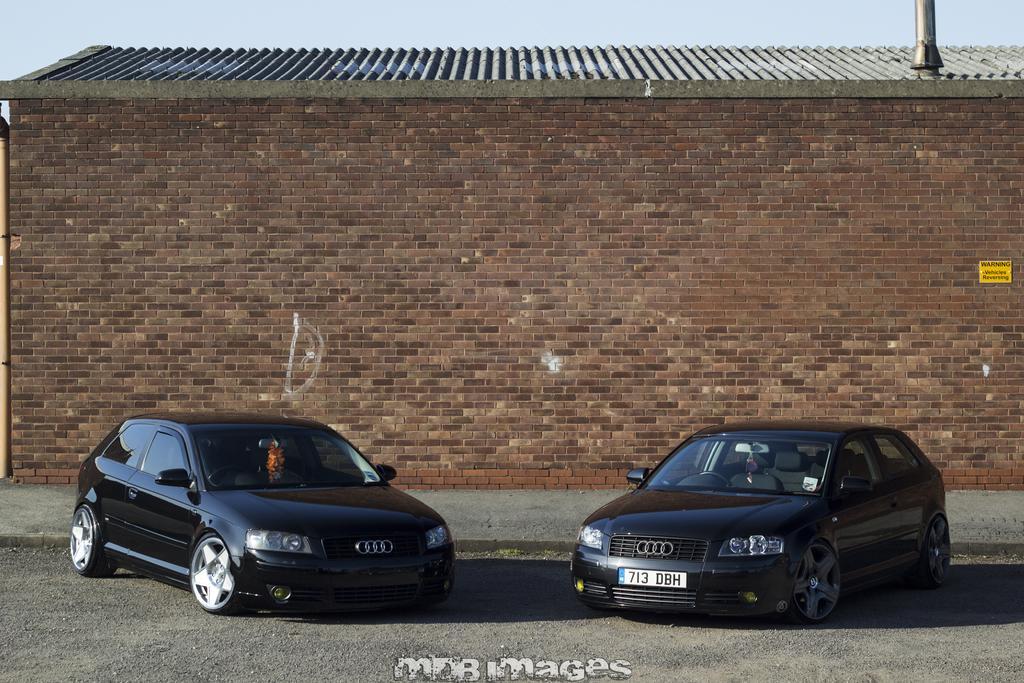Could you give a brief overview of what you see in this image? In the picture there are two cars on the road and behind the cars there is a brick wall. 